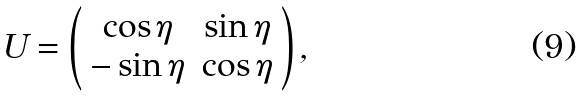<formula> <loc_0><loc_0><loc_500><loc_500>U = \left ( \begin{array} { c c } \cos \eta & \sin \eta \\ - \sin \eta & \cos \eta \end{array} \right ) ,</formula> 